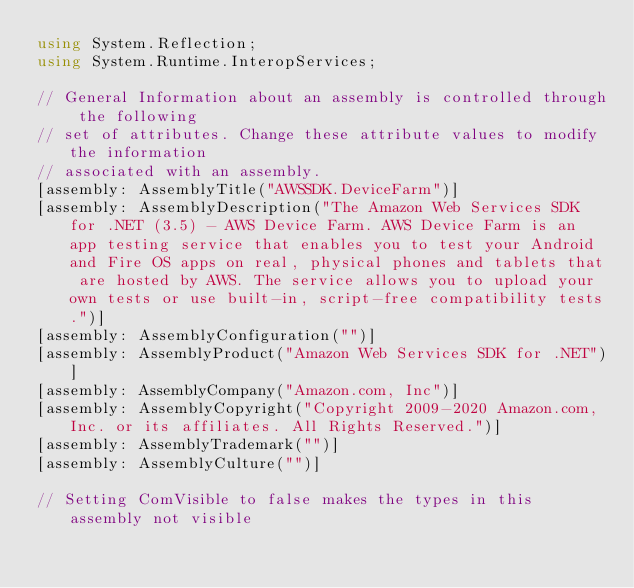<code> <loc_0><loc_0><loc_500><loc_500><_C#_>using System.Reflection;
using System.Runtime.InteropServices;

// General Information about an assembly is controlled through the following 
// set of attributes. Change these attribute values to modify the information
// associated with an assembly.
[assembly: AssemblyTitle("AWSSDK.DeviceFarm")]
[assembly: AssemblyDescription("The Amazon Web Services SDK for .NET (3.5) - AWS Device Farm. AWS Device Farm is an app testing service that enables you to test your Android and Fire OS apps on real, physical phones and tablets that are hosted by AWS. The service allows you to upload your own tests or use built-in, script-free compatibility tests.")]
[assembly: AssemblyConfiguration("")]
[assembly: AssemblyProduct("Amazon Web Services SDK for .NET")]
[assembly: AssemblyCompany("Amazon.com, Inc")]
[assembly: AssemblyCopyright("Copyright 2009-2020 Amazon.com, Inc. or its affiliates. All Rights Reserved.")]
[assembly: AssemblyTrademark("")]
[assembly: AssemblyCulture("")]

// Setting ComVisible to false makes the types in this assembly not visible </code> 